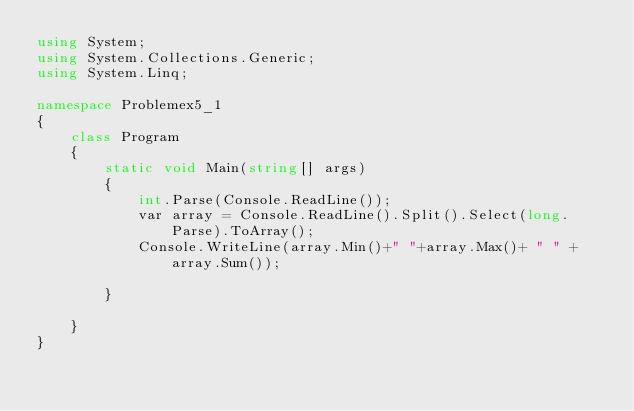<code> <loc_0><loc_0><loc_500><loc_500><_C#_>using System;
using System.Collections.Generic;
using System.Linq;

namespace Problemex5_1
{
	class Program
	{
		static void Main(string[] args)
		{
			int.Parse(Console.ReadLine());
			var array = Console.ReadLine().Split().Select(long.Parse).ToArray();
			Console.WriteLine(array.Min()+" "+array.Max()+ " " + array.Sum());

		}

	}
}</code> 